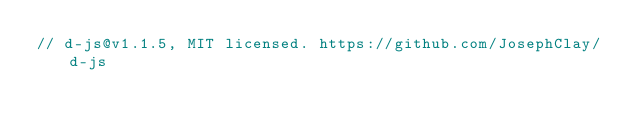<code> <loc_0><loc_0><loc_500><loc_500><_JavaScript_>// d-js@v1.1.5, MIT licensed. https://github.com/JosephClay/d-js</code> 